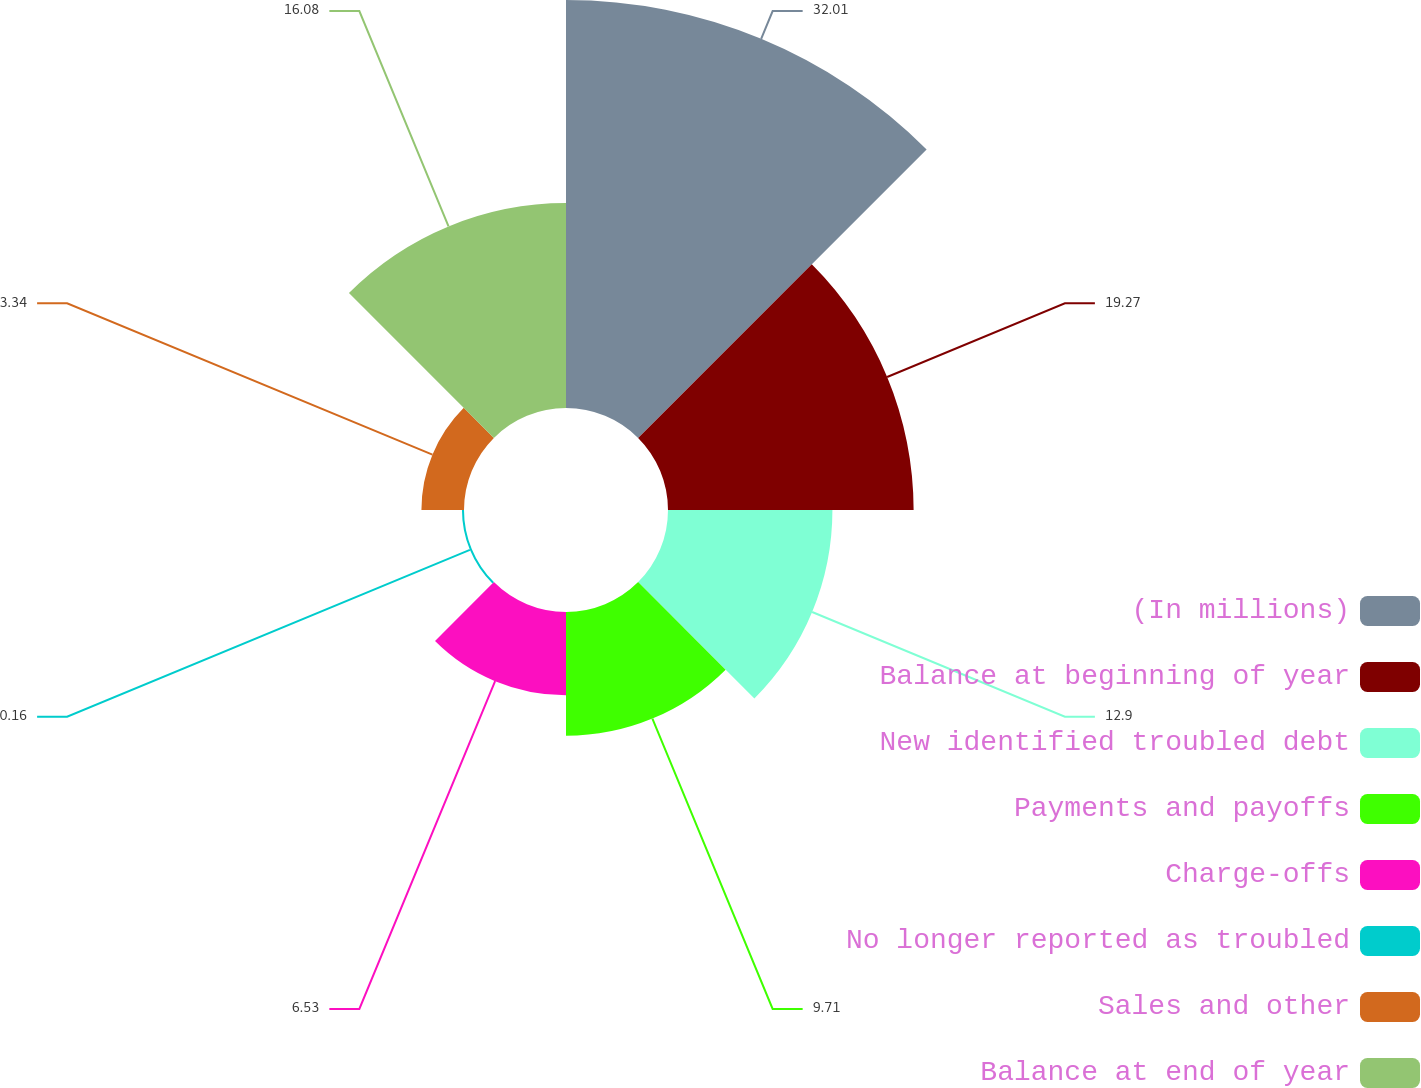Convert chart. <chart><loc_0><loc_0><loc_500><loc_500><pie_chart><fcel>(In millions)<fcel>Balance at beginning of year<fcel>New identified troubled debt<fcel>Payments and payoffs<fcel>Charge-offs<fcel>No longer reported as troubled<fcel>Sales and other<fcel>Balance at end of year<nl><fcel>32.01%<fcel>19.27%<fcel>12.9%<fcel>9.71%<fcel>6.53%<fcel>0.16%<fcel>3.34%<fcel>16.08%<nl></chart> 